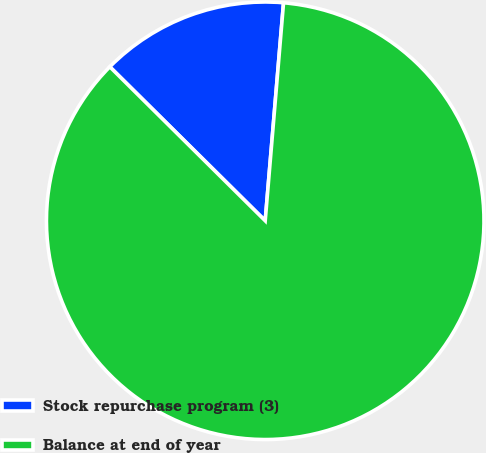Convert chart to OTSL. <chart><loc_0><loc_0><loc_500><loc_500><pie_chart><fcel>Stock repurchase program (3)<fcel>Balance at end of year<nl><fcel>13.91%<fcel>86.09%<nl></chart> 